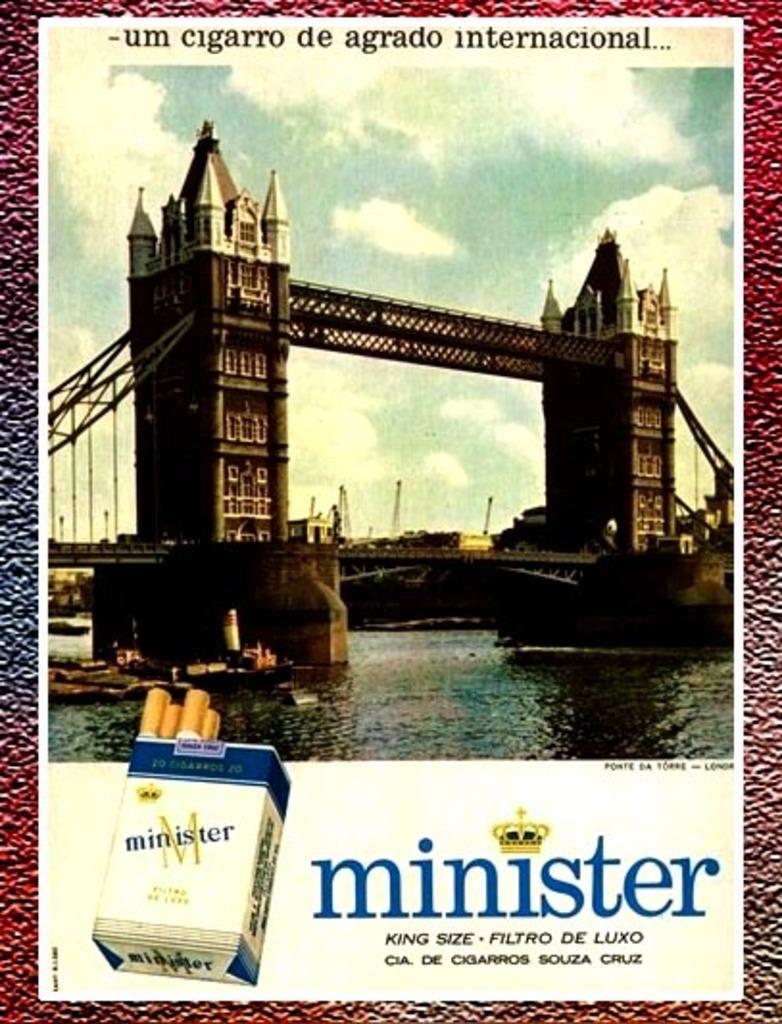<image>
Create a compact narrative representing the image presented. a poster that says 'minister' at the bottom of it 